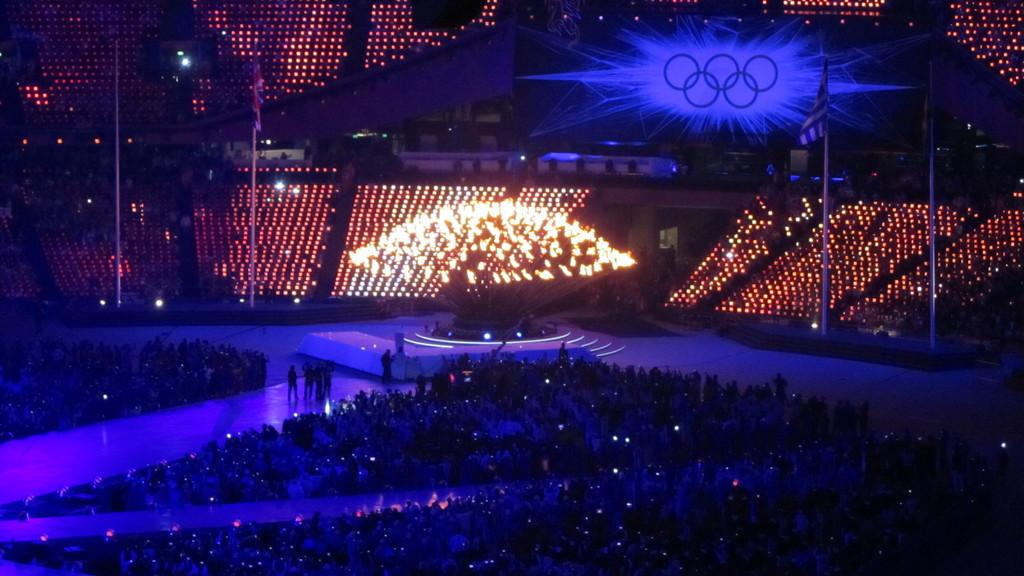What is the main subject of the image? The main subject of the image is a crowd. What objects can be seen in the image besides the crowd? There are poles, flags, lights, and a screen visible in the image. What might the poles be used for in the image? The poles might be used to support flags or lights in the image. What is the purpose of the screen in the background of the image? The screen in the background of the image might be used for displaying information or visuals. How many beds can be seen in the image? There are no beds present in the image. What type of lace can be seen decorating the flags in the image? There is no lace visible on the flags in the image. 